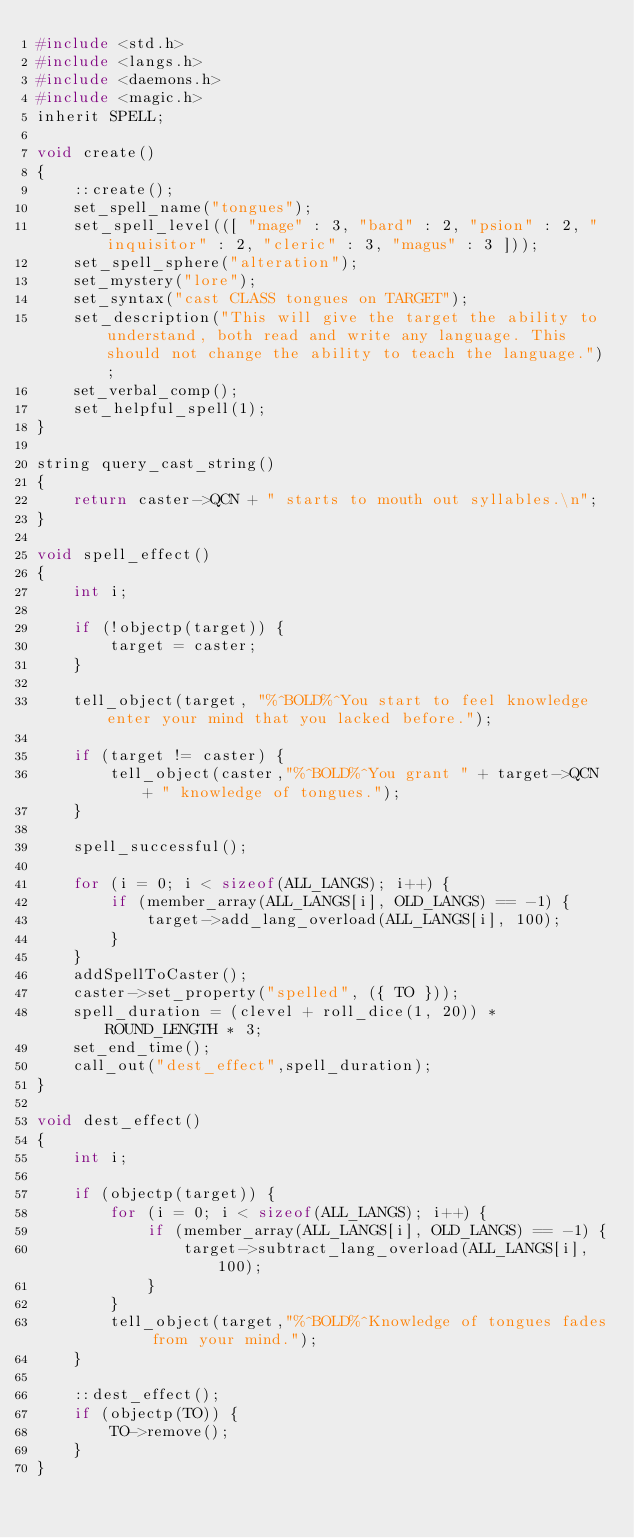Convert code to text. <code><loc_0><loc_0><loc_500><loc_500><_C_>#include <std.h>
#include <langs.h>
#include <daemons.h>
#include <magic.h>
inherit SPELL;

void create()
{
    ::create();
    set_spell_name("tongues");
    set_spell_level(([ "mage" : 3, "bard" : 2, "psion" : 2, "inquisitor" : 2, "cleric" : 3, "magus" : 3 ]));
    set_spell_sphere("alteration");
    set_mystery("lore");
    set_syntax("cast CLASS tongues on TARGET");
    set_description("This will give the target the ability to understand, both read and write any language. This should not change the ability to teach the language.");
    set_verbal_comp();
    set_helpful_spell(1);
}

string query_cast_string()
{
    return caster->QCN + " starts to mouth out syllables.\n";
}

void spell_effect()
{
    int i;

    if (!objectp(target)) {
        target = caster;
    }

    tell_object(target, "%^BOLD%^You start to feel knowledge enter your mind that you lacked before.");

    if (target != caster) {
        tell_object(caster,"%^BOLD%^You grant " + target->QCN + " knowledge of tongues.");
    }

    spell_successful();

    for (i = 0; i < sizeof(ALL_LANGS); i++) {
        if (member_array(ALL_LANGS[i], OLD_LANGS) == -1) {
            target->add_lang_overload(ALL_LANGS[i], 100);
        }
    }
    addSpellToCaster();
    caster->set_property("spelled", ({ TO }));
    spell_duration = (clevel + roll_dice(1, 20)) * ROUND_LENGTH * 3;
    set_end_time();
    call_out("dest_effect",spell_duration);
}

void dest_effect()
{
    int i;

    if (objectp(target)) {
        for (i = 0; i < sizeof(ALL_LANGS); i++) {
            if (member_array(ALL_LANGS[i], OLD_LANGS) == -1) {
                target->subtract_lang_overload(ALL_LANGS[i], 100);
            }
        }
        tell_object(target,"%^BOLD%^Knowledge of tongues fades from your mind.");
    }

    ::dest_effect();
    if (objectp(TO)) {
        TO->remove();
    }
}
</code> 